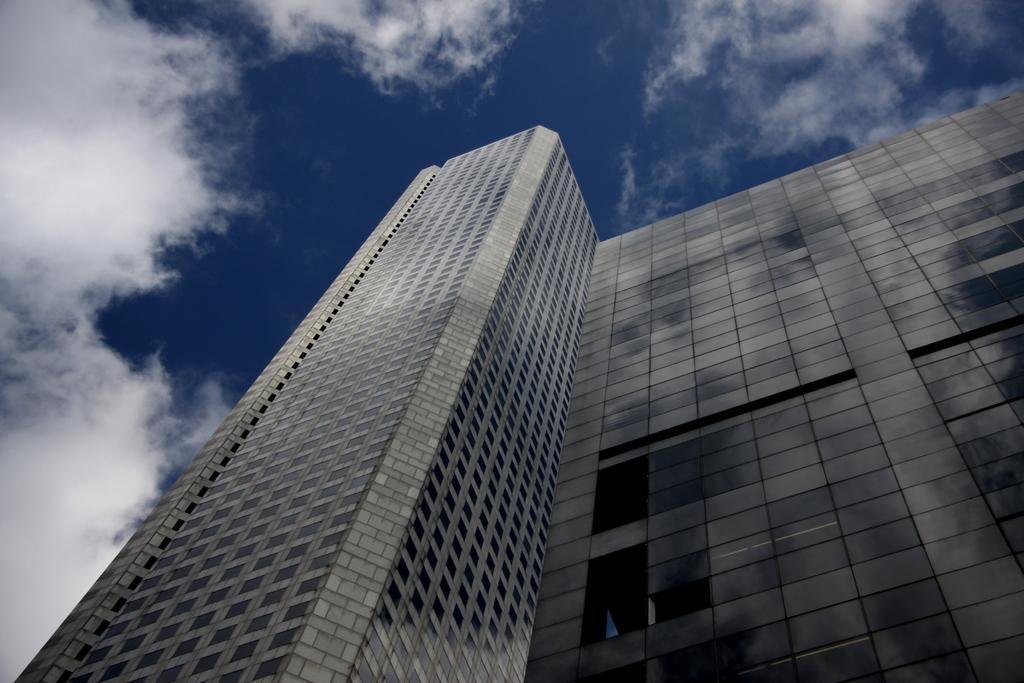Describe this image in one or two sentences. In this image, we can see building and at the top, there is sky. 